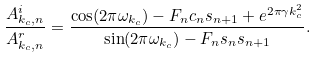Convert formula to latex. <formula><loc_0><loc_0><loc_500><loc_500>\frac { A _ { k _ { c } , n } ^ { i } } { A _ { k _ { c } , n } ^ { r } } = \frac { \cos ( 2 \pi \omega _ { k _ { c } } ) - F _ { n } c _ { n } s _ { n + 1 } + e ^ { 2 \pi \gamma k _ { c } ^ { 2 } } } { \sin ( 2 \pi \omega _ { k _ { c } } ) - F _ { n } s _ { n } s _ { n + 1 } } .</formula> 